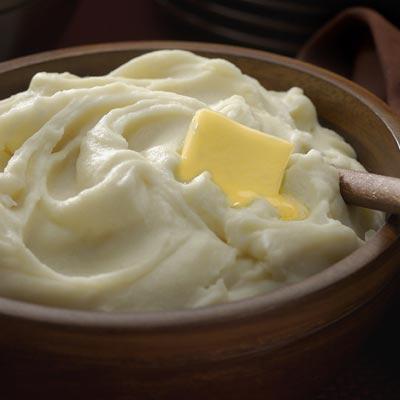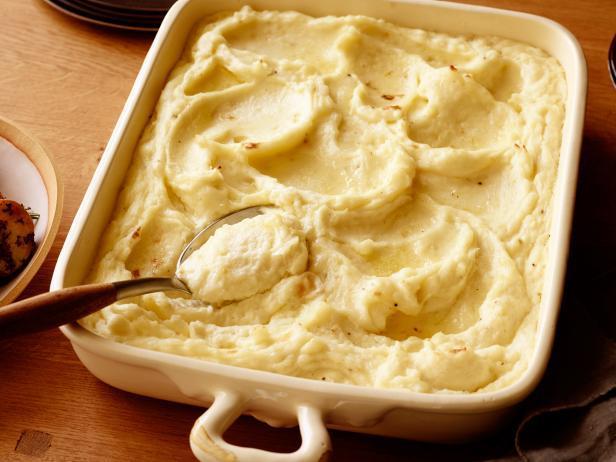The first image is the image on the left, the second image is the image on the right. Given the left and right images, does the statement "An image contains mashed potatoes with a spoon inside it." hold true? Answer yes or no. Yes. 